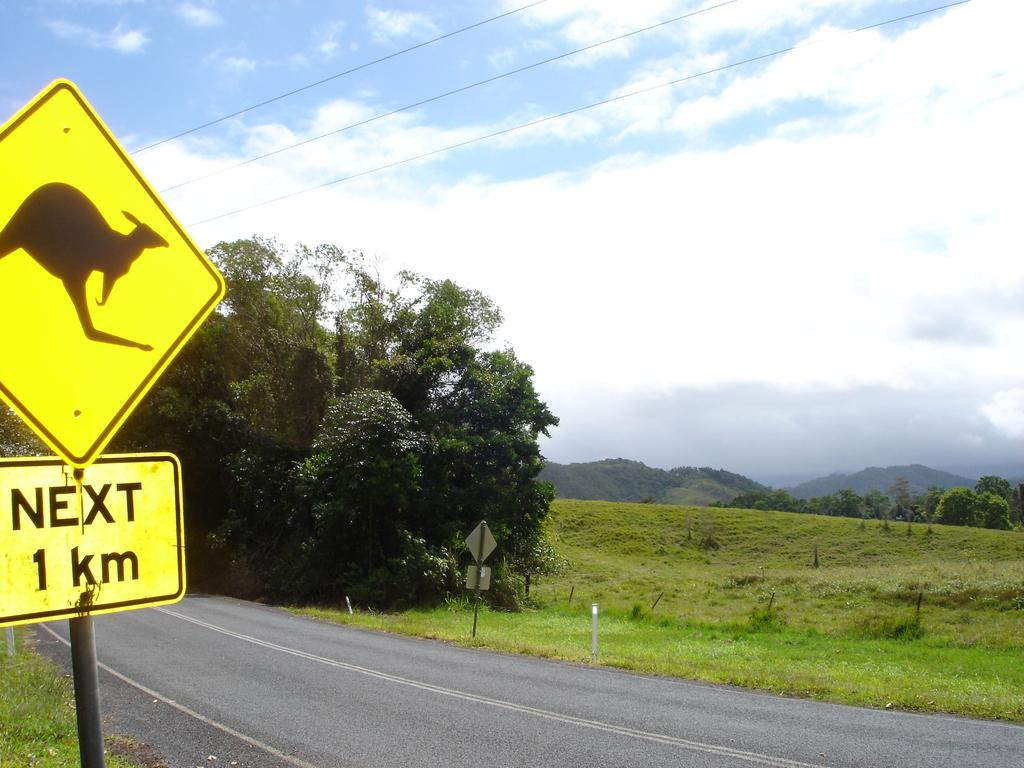<image>
Share a concise interpretation of the image provided. Kangaroo crossing signs are posted along side this road. 